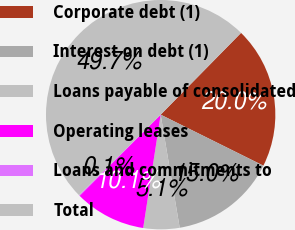Convert chart. <chart><loc_0><loc_0><loc_500><loc_500><pie_chart><fcel>Corporate debt (1)<fcel>Interest on debt (1)<fcel>Loans payable of consolidated<fcel>Operating leases<fcel>Loans and commitments to<fcel>Total<nl><fcel>19.97%<fcel>15.01%<fcel>5.09%<fcel>10.05%<fcel>0.13%<fcel>49.74%<nl></chart> 